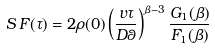Convert formula to latex. <formula><loc_0><loc_0><loc_500><loc_500>S \, F ( \tau ) = 2 \rho ( 0 ) \left ( \frac { v \tau } { D \theta } \right ) ^ { \beta - 3 } \frac { G _ { 1 } ( \beta ) } { F _ { 1 } ( \beta ) }</formula> 